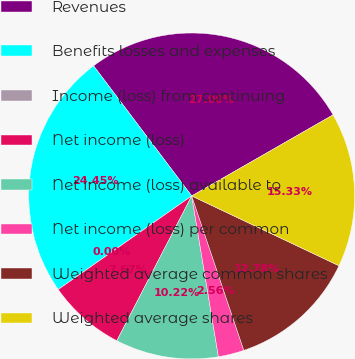Convert chart. <chart><loc_0><loc_0><loc_500><loc_500><pie_chart><fcel>Revenues<fcel>Benefits losses and expenses<fcel>Income (loss) from continuing<fcel>Net income (loss)<fcel>Net income (loss) available to<fcel>Net income (loss) per common<fcel>Weighted average common shares<fcel>Weighted average shares<nl><fcel>27.0%<fcel>24.45%<fcel>0.0%<fcel>7.67%<fcel>10.22%<fcel>2.56%<fcel>12.78%<fcel>15.33%<nl></chart> 